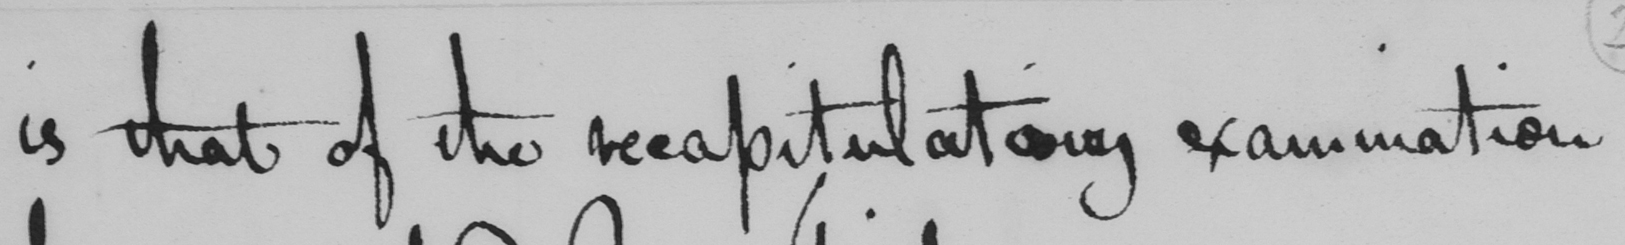Can you read and transcribe this handwriting? is that of the recapitulatory examination 